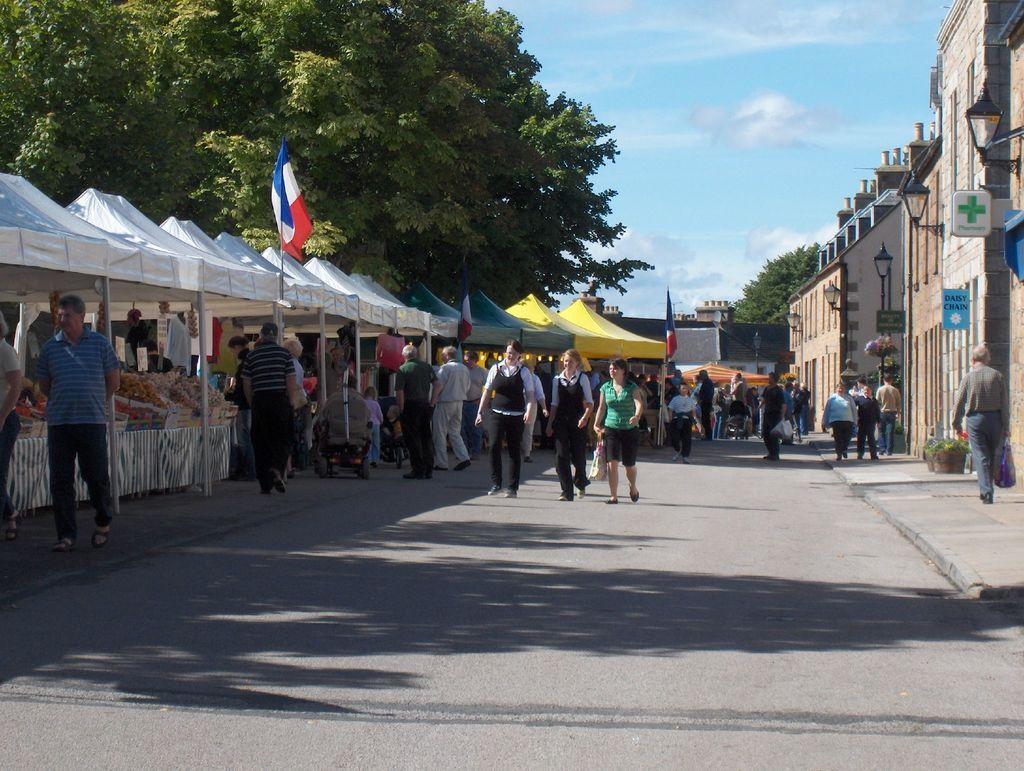Describe this image in one or two sentences. In the foreground of this image, there are people walking on the road. On the left, there are few tents, flags, few objects and the people. On the right, there are buildings, poles, boards and few people walking on the side path. In the background, there are buildings, trees and the sky. 